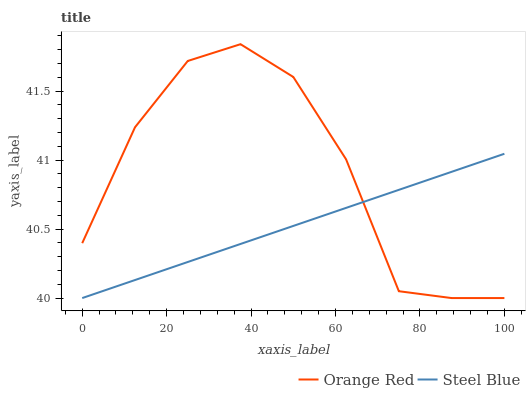Does Steel Blue have the maximum area under the curve?
Answer yes or no. No. Is Steel Blue the roughest?
Answer yes or no. No. Does Steel Blue have the highest value?
Answer yes or no. No. 